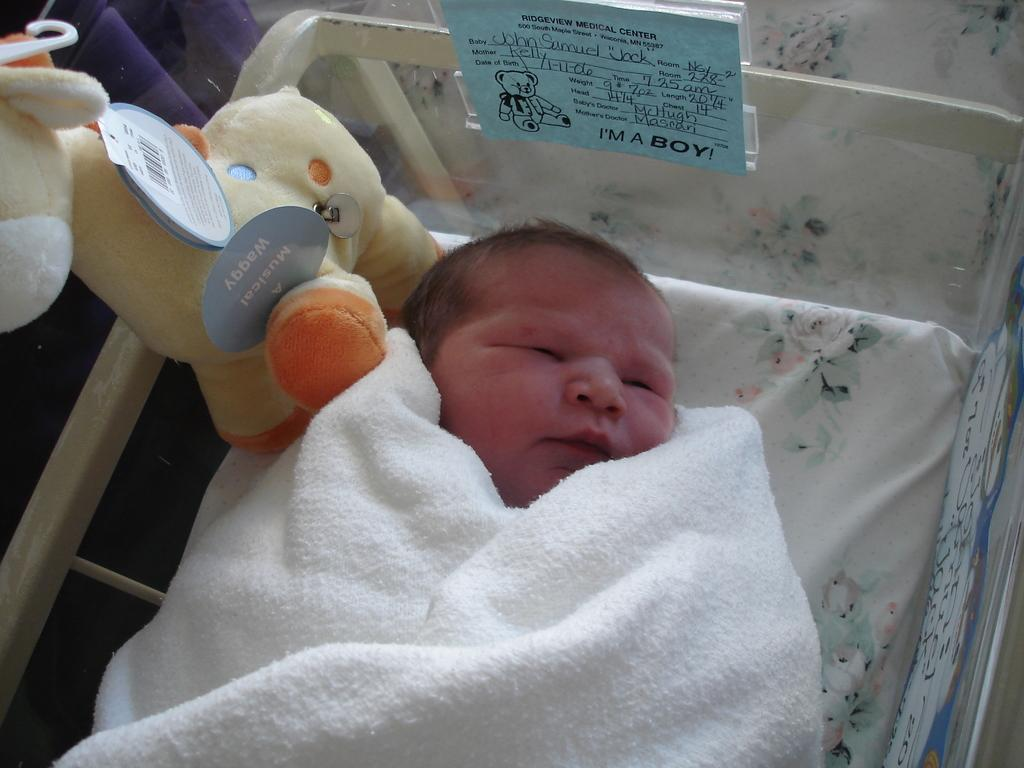What is the main subject of the image? The main subject of the image is an infant. What is the infant doing in the image? The infant is sleeping in the image. Where is the infant sleeping? The infant is sleeping in a cradle. Is there anything else near the infant? Yes, there is a toy beside the infant. How is the infant dressed or covered in the image? The infant is wrapped in a towel. What type of soup is being served in the image? There is no soup present in the image; it features an infant sleeping in a cradle. What type of print can be seen on the towel wrapped around the infant? There is no print visible on the towel wrapped around the infant in the image. 